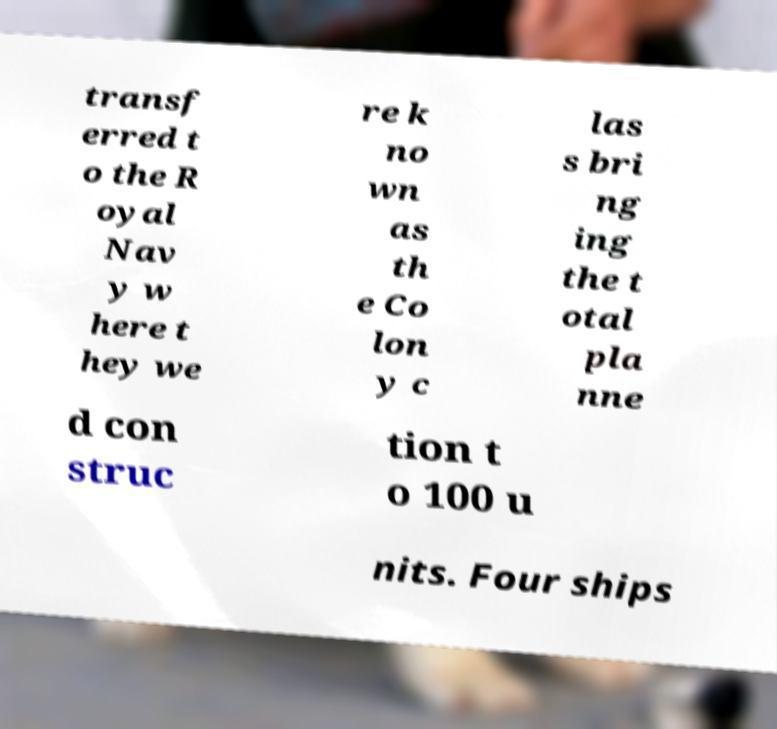Can you accurately transcribe the text from the provided image for me? transf erred t o the R oyal Nav y w here t hey we re k no wn as th e Co lon y c las s bri ng ing the t otal pla nne d con struc tion t o 100 u nits. Four ships 